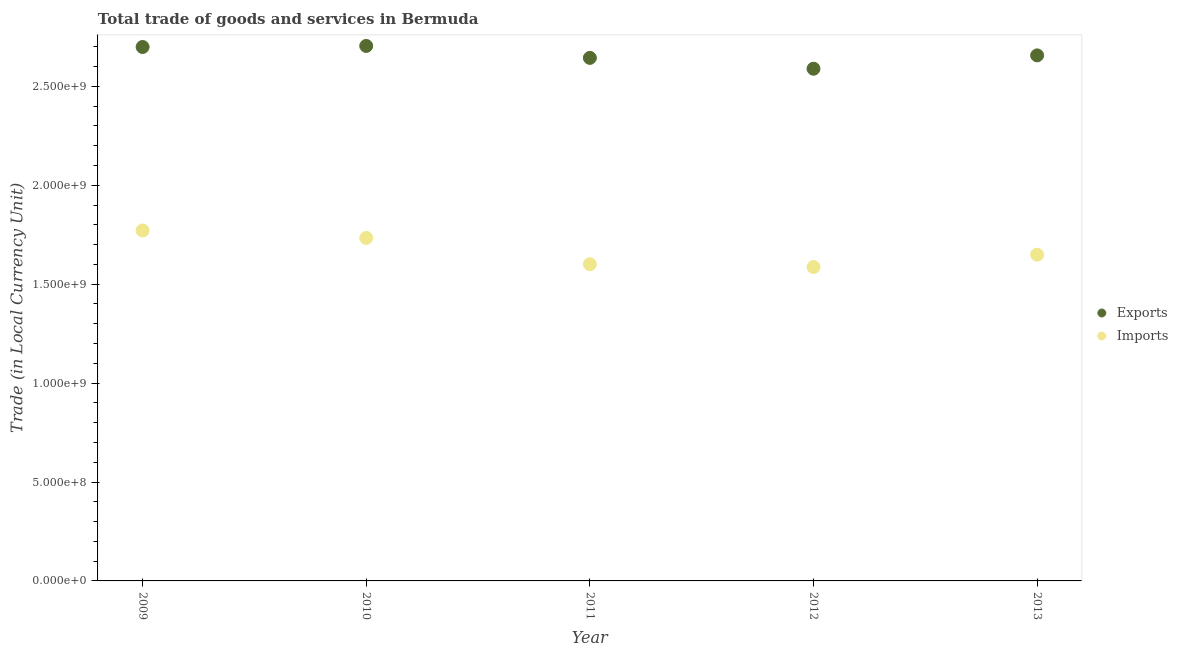How many different coloured dotlines are there?
Ensure brevity in your answer.  2. Is the number of dotlines equal to the number of legend labels?
Offer a terse response. Yes. What is the imports of goods and services in 2010?
Provide a short and direct response. 1.73e+09. Across all years, what is the maximum imports of goods and services?
Keep it short and to the point. 1.77e+09. Across all years, what is the minimum export of goods and services?
Your response must be concise. 2.59e+09. In which year was the imports of goods and services maximum?
Provide a short and direct response. 2009. What is the total export of goods and services in the graph?
Ensure brevity in your answer.  1.33e+1. What is the difference between the imports of goods and services in 2009 and that in 2011?
Give a very brief answer. 1.71e+08. What is the difference between the export of goods and services in 2013 and the imports of goods and services in 2009?
Your answer should be compact. 8.85e+08. What is the average imports of goods and services per year?
Offer a very short reply. 1.67e+09. In the year 2012, what is the difference between the export of goods and services and imports of goods and services?
Offer a very short reply. 1.00e+09. What is the ratio of the export of goods and services in 2010 to that in 2013?
Give a very brief answer. 1.02. What is the difference between the highest and the second highest imports of goods and services?
Offer a very short reply. 3.76e+07. What is the difference between the highest and the lowest export of goods and services?
Ensure brevity in your answer.  1.15e+08. In how many years, is the imports of goods and services greater than the average imports of goods and services taken over all years?
Keep it short and to the point. 2. Is the imports of goods and services strictly greater than the export of goods and services over the years?
Make the answer very short. No. How many dotlines are there?
Make the answer very short. 2. What is the difference between two consecutive major ticks on the Y-axis?
Offer a terse response. 5.00e+08. Does the graph contain grids?
Give a very brief answer. No. Where does the legend appear in the graph?
Offer a terse response. Center right. How are the legend labels stacked?
Make the answer very short. Vertical. What is the title of the graph?
Make the answer very short. Total trade of goods and services in Bermuda. What is the label or title of the Y-axis?
Your answer should be very brief. Trade (in Local Currency Unit). What is the Trade (in Local Currency Unit) in Exports in 2009?
Give a very brief answer. 2.70e+09. What is the Trade (in Local Currency Unit) in Imports in 2009?
Your response must be concise. 1.77e+09. What is the Trade (in Local Currency Unit) in Exports in 2010?
Ensure brevity in your answer.  2.70e+09. What is the Trade (in Local Currency Unit) of Imports in 2010?
Your answer should be compact. 1.73e+09. What is the Trade (in Local Currency Unit) of Exports in 2011?
Your answer should be very brief. 2.64e+09. What is the Trade (in Local Currency Unit) in Imports in 2011?
Your answer should be compact. 1.60e+09. What is the Trade (in Local Currency Unit) of Exports in 2012?
Provide a succinct answer. 2.59e+09. What is the Trade (in Local Currency Unit) of Imports in 2012?
Make the answer very short. 1.59e+09. What is the Trade (in Local Currency Unit) of Exports in 2013?
Offer a very short reply. 2.66e+09. What is the Trade (in Local Currency Unit) of Imports in 2013?
Ensure brevity in your answer.  1.65e+09. Across all years, what is the maximum Trade (in Local Currency Unit) in Exports?
Give a very brief answer. 2.70e+09. Across all years, what is the maximum Trade (in Local Currency Unit) of Imports?
Provide a succinct answer. 1.77e+09. Across all years, what is the minimum Trade (in Local Currency Unit) in Exports?
Your answer should be compact. 2.59e+09. Across all years, what is the minimum Trade (in Local Currency Unit) in Imports?
Provide a succinct answer. 1.59e+09. What is the total Trade (in Local Currency Unit) in Exports in the graph?
Your answer should be very brief. 1.33e+1. What is the total Trade (in Local Currency Unit) in Imports in the graph?
Provide a short and direct response. 8.34e+09. What is the difference between the Trade (in Local Currency Unit) of Exports in 2009 and that in 2010?
Provide a short and direct response. -5.34e+06. What is the difference between the Trade (in Local Currency Unit) in Imports in 2009 and that in 2010?
Your response must be concise. 3.76e+07. What is the difference between the Trade (in Local Currency Unit) in Exports in 2009 and that in 2011?
Provide a succinct answer. 5.51e+07. What is the difference between the Trade (in Local Currency Unit) of Imports in 2009 and that in 2011?
Your answer should be very brief. 1.71e+08. What is the difference between the Trade (in Local Currency Unit) of Exports in 2009 and that in 2012?
Provide a succinct answer. 1.10e+08. What is the difference between the Trade (in Local Currency Unit) in Imports in 2009 and that in 2012?
Offer a very short reply. 1.85e+08. What is the difference between the Trade (in Local Currency Unit) of Exports in 2009 and that in 2013?
Keep it short and to the point. 4.24e+07. What is the difference between the Trade (in Local Currency Unit) of Imports in 2009 and that in 2013?
Your response must be concise. 1.22e+08. What is the difference between the Trade (in Local Currency Unit) of Exports in 2010 and that in 2011?
Your answer should be compact. 6.04e+07. What is the difference between the Trade (in Local Currency Unit) in Imports in 2010 and that in 2011?
Give a very brief answer. 1.33e+08. What is the difference between the Trade (in Local Currency Unit) of Exports in 2010 and that in 2012?
Offer a terse response. 1.15e+08. What is the difference between the Trade (in Local Currency Unit) of Imports in 2010 and that in 2012?
Give a very brief answer. 1.47e+08. What is the difference between the Trade (in Local Currency Unit) of Exports in 2010 and that in 2013?
Keep it short and to the point. 4.78e+07. What is the difference between the Trade (in Local Currency Unit) of Imports in 2010 and that in 2013?
Ensure brevity in your answer.  8.46e+07. What is the difference between the Trade (in Local Currency Unit) in Exports in 2011 and that in 2012?
Make the answer very short. 5.48e+07. What is the difference between the Trade (in Local Currency Unit) of Imports in 2011 and that in 2012?
Your answer should be very brief. 1.42e+07. What is the difference between the Trade (in Local Currency Unit) of Exports in 2011 and that in 2013?
Your response must be concise. -1.27e+07. What is the difference between the Trade (in Local Currency Unit) of Imports in 2011 and that in 2013?
Keep it short and to the point. -4.84e+07. What is the difference between the Trade (in Local Currency Unit) in Exports in 2012 and that in 2013?
Your response must be concise. -6.75e+07. What is the difference between the Trade (in Local Currency Unit) in Imports in 2012 and that in 2013?
Make the answer very short. -6.26e+07. What is the difference between the Trade (in Local Currency Unit) in Exports in 2009 and the Trade (in Local Currency Unit) in Imports in 2010?
Keep it short and to the point. 9.65e+08. What is the difference between the Trade (in Local Currency Unit) of Exports in 2009 and the Trade (in Local Currency Unit) of Imports in 2011?
Provide a short and direct response. 1.10e+09. What is the difference between the Trade (in Local Currency Unit) in Exports in 2009 and the Trade (in Local Currency Unit) in Imports in 2012?
Make the answer very short. 1.11e+09. What is the difference between the Trade (in Local Currency Unit) in Exports in 2009 and the Trade (in Local Currency Unit) in Imports in 2013?
Your response must be concise. 1.05e+09. What is the difference between the Trade (in Local Currency Unit) in Exports in 2010 and the Trade (in Local Currency Unit) in Imports in 2011?
Ensure brevity in your answer.  1.10e+09. What is the difference between the Trade (in Local Currency Unit) in Exports in 2010 and the Trade (in Local Currency Unit) in Imports in 2012?
Your response must be concise. 1.12e+09. What is the difference between the Trade (in Local Currency Unit) of Exports in 2010 and the Trade (in Local Currency Unit) of Imports in 2013?
Offer a very short reply. 1.06e+09. What is the difference between the Trade (in Local Currency Unit) of Exports in 2011 and the Trade (in Local Currency Unit) of Imports in 2012?
Your answer should be very brief. 1.06e+09. What is the difference between the Trade (in Local Currency Unit) in Exports in 2011 and the Trade (in Local Currency Unit) in Imports in 2013?
Offer a terse response. 9.95e+08. What is the difference between the Trade (in Local Currency Unit) in Exports in 2012 and the Trade (in Local Currency Unit) in Imports in 2013?
Your answer should be very brief. 9.40e+08. What is the average Trade (in Local Currency Unit) of Exports per year?
Offer a very short reply. 2.66e+09. What is the average Trade (in Local Currency Unit) of Imports per year?
Your answer should be compact. 1.67e+09. In the year 2009, what is the difference between the Trade (in Local Currency Unit) of Exports and Trade (in Local Currency Unit) of Imports?
Keep it short and to the point. 9.28e+08. In the year 2010, what is the difference between the Trade (in Local Currency Unit) of Exports and Trade (in Local Currency Unit) of Imports?
Provide a short and direct response. 9.71e+08. In the year 2011, what is the difference between the Trade (in Local Currency Unit) of Exports and Trade (in Local Currency Unit) of Imports?
Keep it short and to the point. 1.04e+09. In the year 2012, what is the difference between the Trade (in Local Currency Unit) of Exports and Trade (in Local Currency Unit) of Imports?
Provide a succinct answer. 1.00e+09. In the year 2013, what is the difference between the Trade (in Local Currency Unit) in Exports and Trade (in Local Currency Unit) in Imports?
Keep it short and to the point. 1.01e+09. What is the ratio of the Trade (in Local Currency Unit) in Exports in 2009 to that in 2010?
Provide a short and direct response. 1. What is the ratio of the Trade (in Local Currency Unit) in Imports in 2009 to that in 2010?
Offer a very short reply. 1.02. What is the ratio of the Trade (in Local Currency Unit) in Exports in 2009 to that in 2011?
Your response must be concise. 1.02. What is the ratio of the Trade (in Local Currency Unit) of Imports in 2009 to that in 2011?
Keep it short and to the point. 1.11. What is the ratio of the Trade (in Local Currency Unit) in Exports in 2009 to that in 2012?
Make the answer very short. 1.04. What is the ratio of the Trade (in Local Currency Unit) in Imports in 2009 to that in 2012?
Offer a very short reply. 1.12. What is the ratio of the Trade (in Local Currency Unit) in Imports in 2009 to that in 2013?
Ensure brevity in your answer.  1.07. What is the ratio of the Trade (in Local Currency Unit) in Exports in 2010 to that in 2011?
Offer a very short reply. 1.02. What is the ratio of the Trade (in Local Currency Unit) in Imports in 2010 to that in 2011?
Keep it short and to the point. 1.08. What is the ratio of the Trade (in Local Currency Unit) of Exports in 2010 to that in 2012?
Provide a short and direct response. 1.04. What is the ratio of the Trade (in Local Currency Unit) of Imports in 2010 to that in 2012?
Your answer should be compact. 1.09. What is the ratio of the Trade (in Local Currency Unit) of Imports in 2010 to that in 2013?
Make the answer very short. 1.05. What is the ratio of the Trade (in Local Currency Unit) of Exports in 2011 to that in 2012?
Offer a very short reply. 1.02. What is the ratio of the Trade (in Local Currency Unit) of Imports in 2011 to that in 2012?
Your answer should be compact. 1.01. What is the ratio of the Trade (in Local Currency Unit) of Imports in 2011 to that in 2013?
Offer a very short reply. 0.97. What is the ratio of the Trade (in Local Currency Unit) of Exports in 2012 to that in 2013?
Keep it short and to the point. 0.97. What is the difference between the highest and the second highest Trade (in Local Currency Unit) of Exports?
Give a very brief answer. 5.34e+06. What is the difference between the highest and the second highest Trade (in Local Currency Unit) of Imports?
Your response must be concise. 3.76e+07. What is the difference between the highest and the lowest Trade (in Local Currency Unit) in Exports?
Keep it short and to the point. 1.15e+08. What is the difference between the highest and the lowest Trade (in Local Currency Unit) in Imports?
Provide a succinct answer. 1.85e+08. 